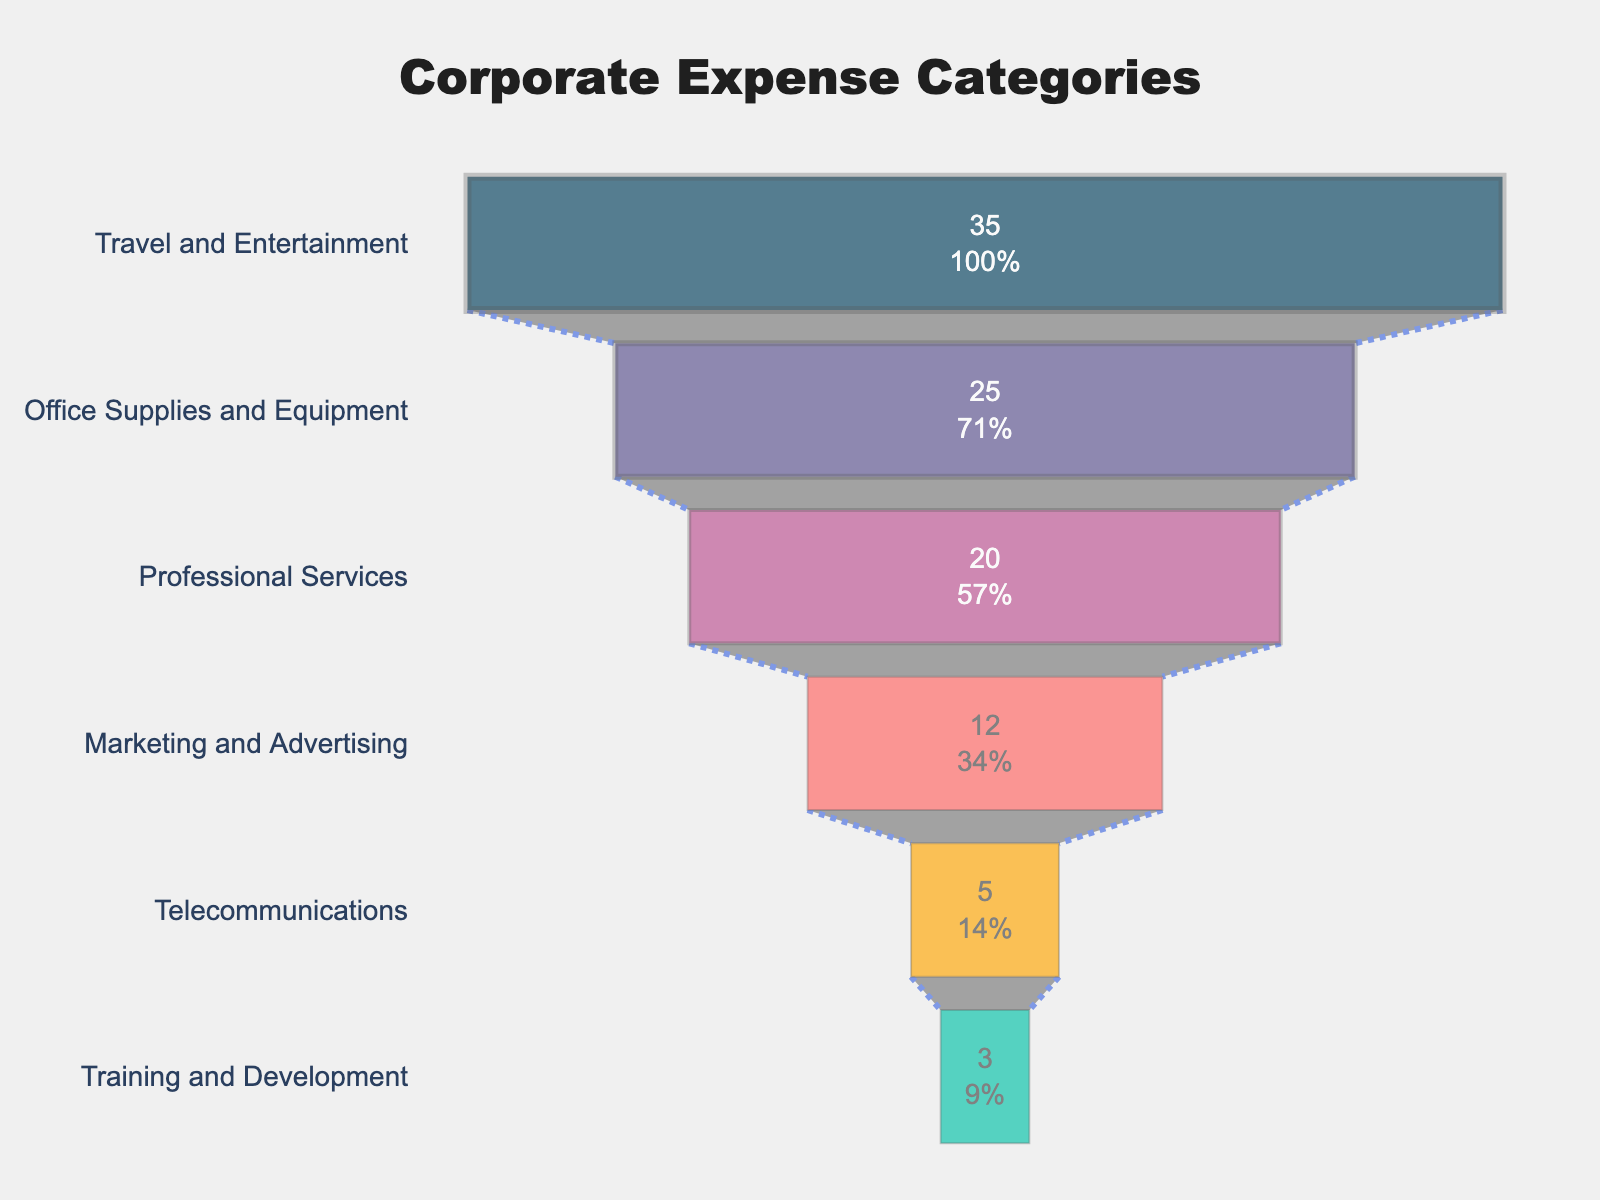Which expense category has the highest percentage? The highest segment in the funnel chart represents the category with the highest percentage, which is "Travel and Entertainment" at the top of the chart.
Answer: Travel and Entertainment What is the percentage of total spending for Office Supplies and Equipment? Locate the "Office Supplies and Equipment" segment in the chart, and note its associated percentage, which is 25%.
Answer: 25% How do the percentages for Marketing and Advertising and Professional Services compare? By observing the funnel chart, "Professional Services" has a higher percentage (20%) compared to "Marketing and Advertising" (12%).
Answer: Professional Services is higher What is the sum of the percentages for Telecommunications and Training and Development? Add the percentages for "Telecommunications" (5%) and "Training and Development" (3%) from the chart: 5 + 3 = 8.
Answer: 8% What is the difference in percentage between the top and bottom categories? Subtract the percentage of the bottom category "Training and Development" (3%) from the top category "Travel and Entertainment" (35%): 35 - 3 = 32.
Answer: 32% Which categories together make up more than 50% of the total spending? Sum the percentages of the top categories until the total exceeds 50%: "Travel and Entertainment" (35%) + "Office Supplies and Equipment" (25%) = 60%. This combination is more than 50%.
Answer: Travel and Entertainment, Office Supplies and Equipment How does the second highest category compare to the third highest category in terms of percentage? Compare "Office Supplies and Equipment" (25%) with "Professional Services" (20%) and find that the second highest category has a higher percentage.
Answer: Office Supplies and Equipment is higher What color is used for Marketing and Advertising in the funnel chart? Identify the color of the segment labeled "Marketing and Advertising" in the chart, which corresponds to the fourth segment's color #ff6361 (orange).
Answer: Orange Which category is depicted with the smallest line width in the funnel chart? The funnel chart's smallest line width is used for the bottom three segments: "Marketing and Advertising," "Telecommunications," and "Training and Development," with a line width of 1.
Answer: Training and Development What is the combined percentage of the top three spending categories? Sum the percentages for "Travel and Entertainment" (35%), "Office Supplies and Equipment" (25%), and "Professional Services" (20%): 35 + 25 + 20 = 80.
Answer: 80% 